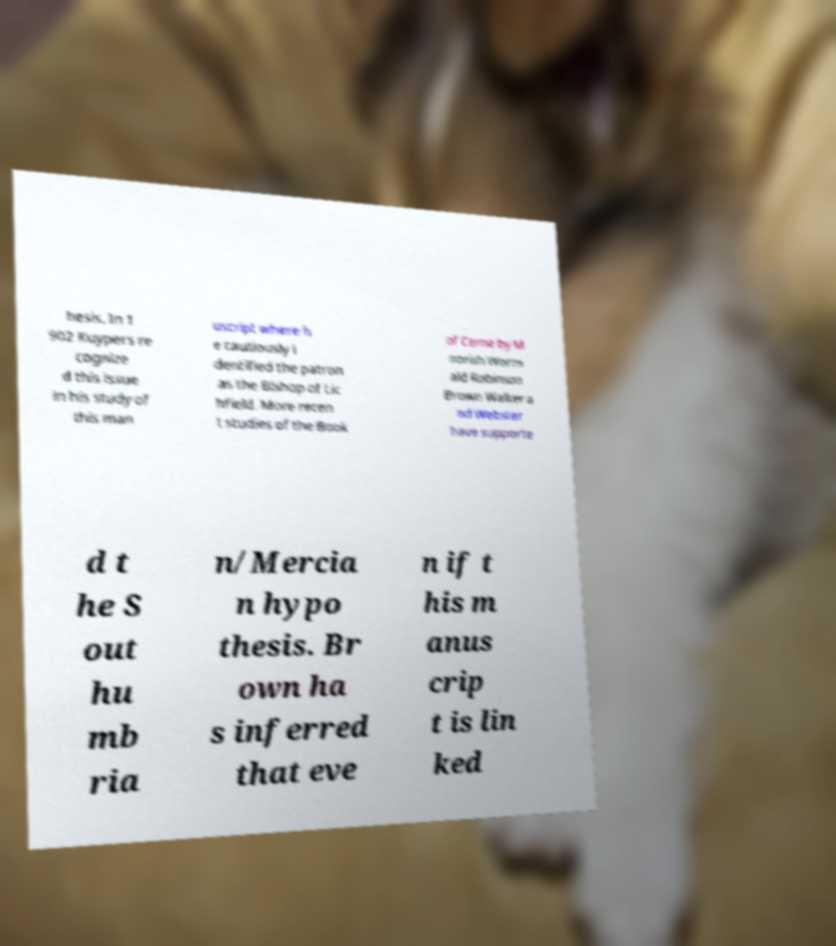Please identify and transcribe the text found in this image. hesis. In 1 902 Kuypers re cognize d this issue in his study of this man uscript where h e cautiously i dentified the patron as the Bishop of Lic hfield. More recen t studies of the Book of Cerne by M oorish Worm ald Robinson Brown Walker a nd Webster have supporte d t he S out hu mb ria n/Mercia n hypo thesis. Br own ha s inferred that eve n if t his m anus crip t is lin ked 